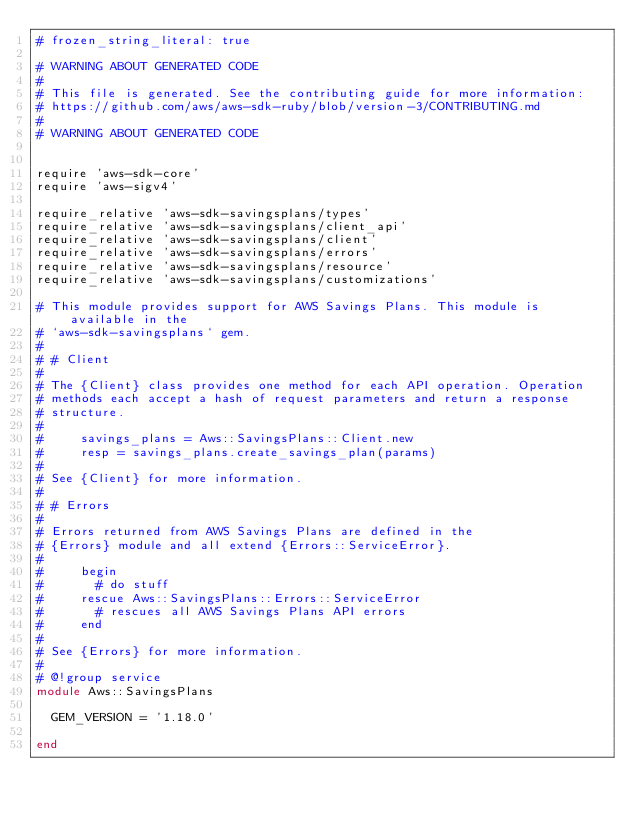<code> <loc_0><loc_0><loc_500><loc_500><_Ruby_># frozen_string_literal: true

# WARNING ABOUT GENERATED CODE
#
# This file is generated. See the contributing guide for more information:
# https://github.com/aws/aws-sdk-ruby/blob/version-3/CONTRIBUTING.md
#
# WARNING ABOUT GENERATED CODE


require 'aws-sdk-core'
require 'aws-sigv4'

require_relative 'aws-sdk-savingsplans/types'
require_relative 'aws-sdk-savingsplans/client_api'
require_relative 'aws-sdk-savingsplans/client'
require_relative 'aws-sdk-savingsplans/errors'
require_relative 'aws-sdk-savingsplans/resource'
require_relative 'aws-sdk-savingsplans/customizations'

# This module provides support for AWS Savings Plans. This module is available in the
# `aws-sdk-savingsplans` gem.
#
# # Client
#
# The {Client} class provides one method for each API operation. Operation
# methods each accept a hash of request parameters and return a response
# structure.
#
#     savings_plans = Aws::SavingsPlans::Client.new
#     resp = savings_plans.create_savings_plan(params)
#
# See {Client} for more information.
#
# # Errors
#
# Errors returned from AWS Savings Plans are defined in the
# {Errors} module and all extend {Errors::ServiceError}.
#
#     begin
#       # do stuff
#     rescue Aws::SavingsPlans::Errors::ServiceError
#       # rescues all AWS Savings Plans API errors
#     end
#
# See {Errors} for more information.
#
# @!group service
module Aws::SavingsPlans

  GEM_VERSION = '1.18.0'

end
</code> 